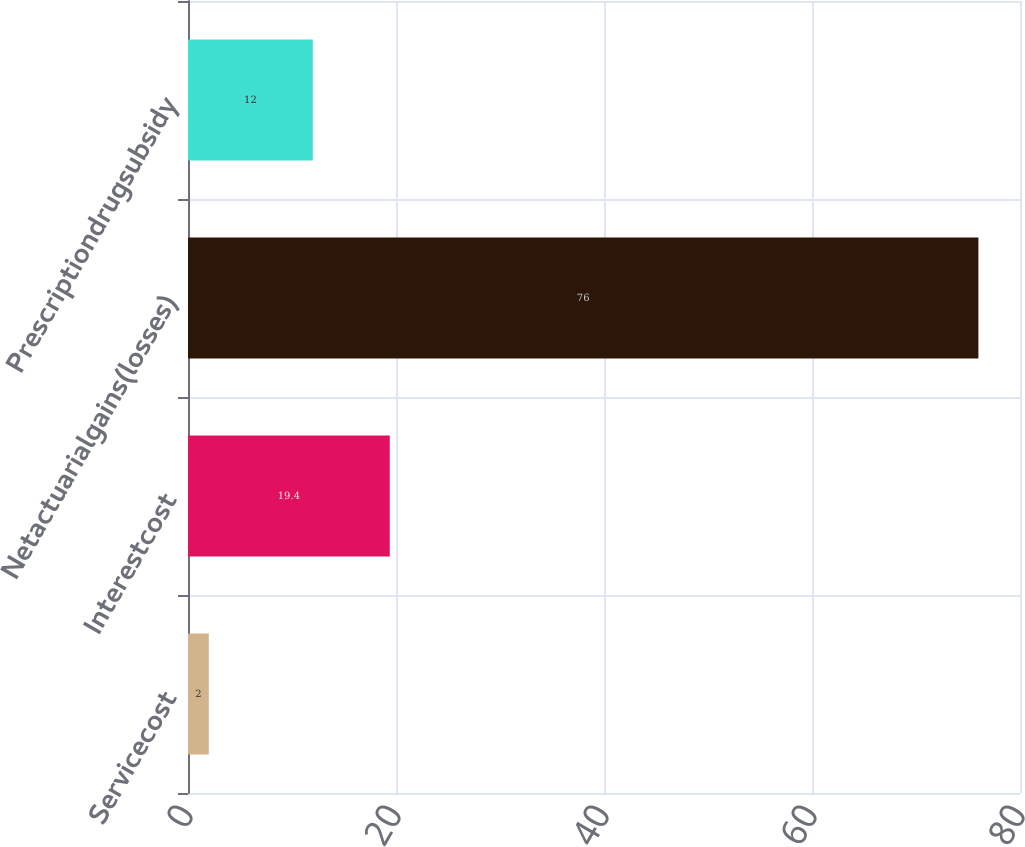Convert chart to OTSL. <chart><loc_0><loc_0><loc_500><loc_500><bar_chart><fcel>Servicecost<fcel>Interestcost<fcel>Netactuarialgains(losses)<fcel>Prescriptiondrugsubsidy<nl><fcel>2<fcel>19.4<fcel>76<fcel>12<nl></chart> 